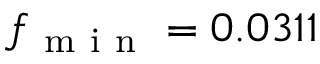Convert formula to latex. <formula><loc_0><loc_0><loc_500><loc_500>f _ { m i n } = 0 . 0 3 1 1</formula> 